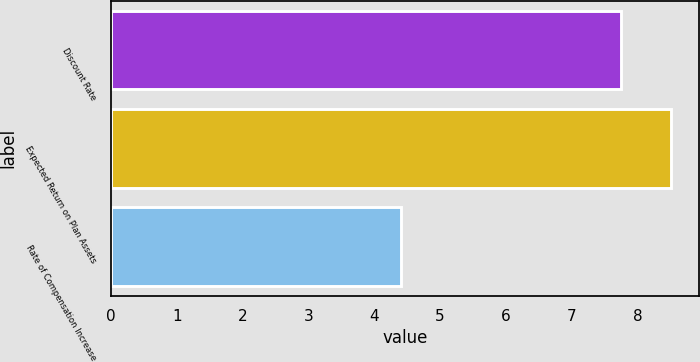Convert chart. <chart><loc_0><loc_0><loc_500><loc_500><bar_chart><fcel>Discount Rate<fcel>Expected Return on Plan Assets<fcel>Rate of Compensation Increase<nl><fcel>7.75<fcel>8.5<fcel>4.4<nl></chart> 